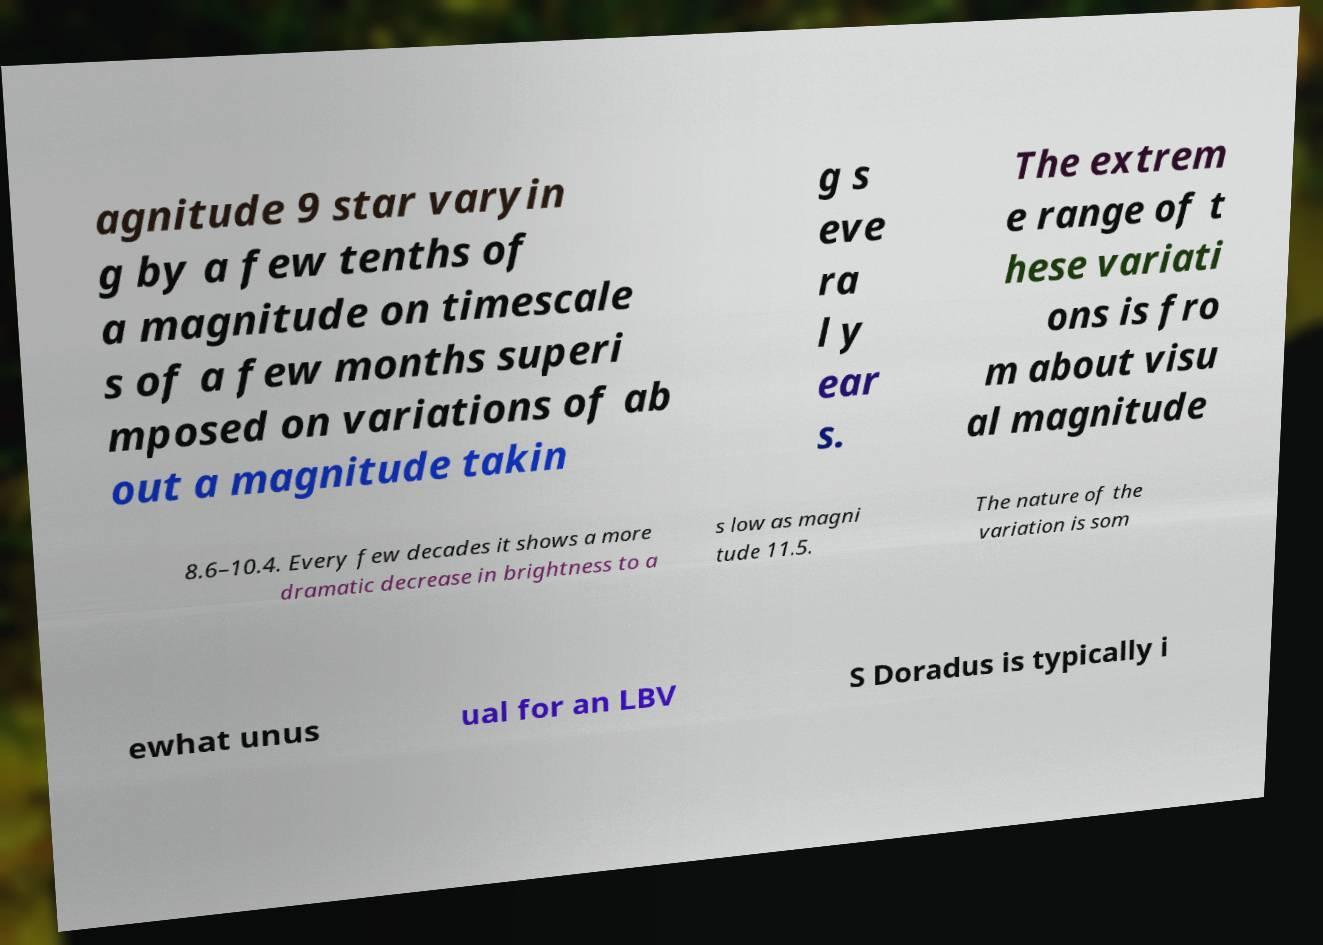Can you read and provide the text displayed in the image?This photo seems to have some interesting text. Can you extract and type it out for me? agnitude 9 star varyin g by a few tenths of a magnitude on timescale s of a few months superi mposed on variations of ab out a magnitude takin g s eve ra l y ear s. The extrem e range of t hese variati ons is fro m about visu al magnitude 8.6–10.4. Every few decades it shows a more dramatic decrease in brightness to a s low as magni tude 11.5. The nature of the variation is som ewhat unus ual for an LBV S Doradus is typically i 